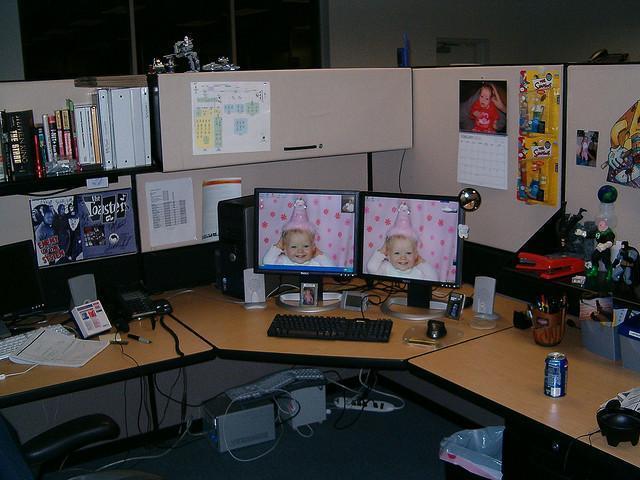How many keyboards are there?
Give a very brief answer. 1. How many computer monitors?
Give a very brief answer. 2. How many people are in the picture?
Give a very brief answer. 2. How many tvs are in the photo?
Give a very brief answer. 2. 